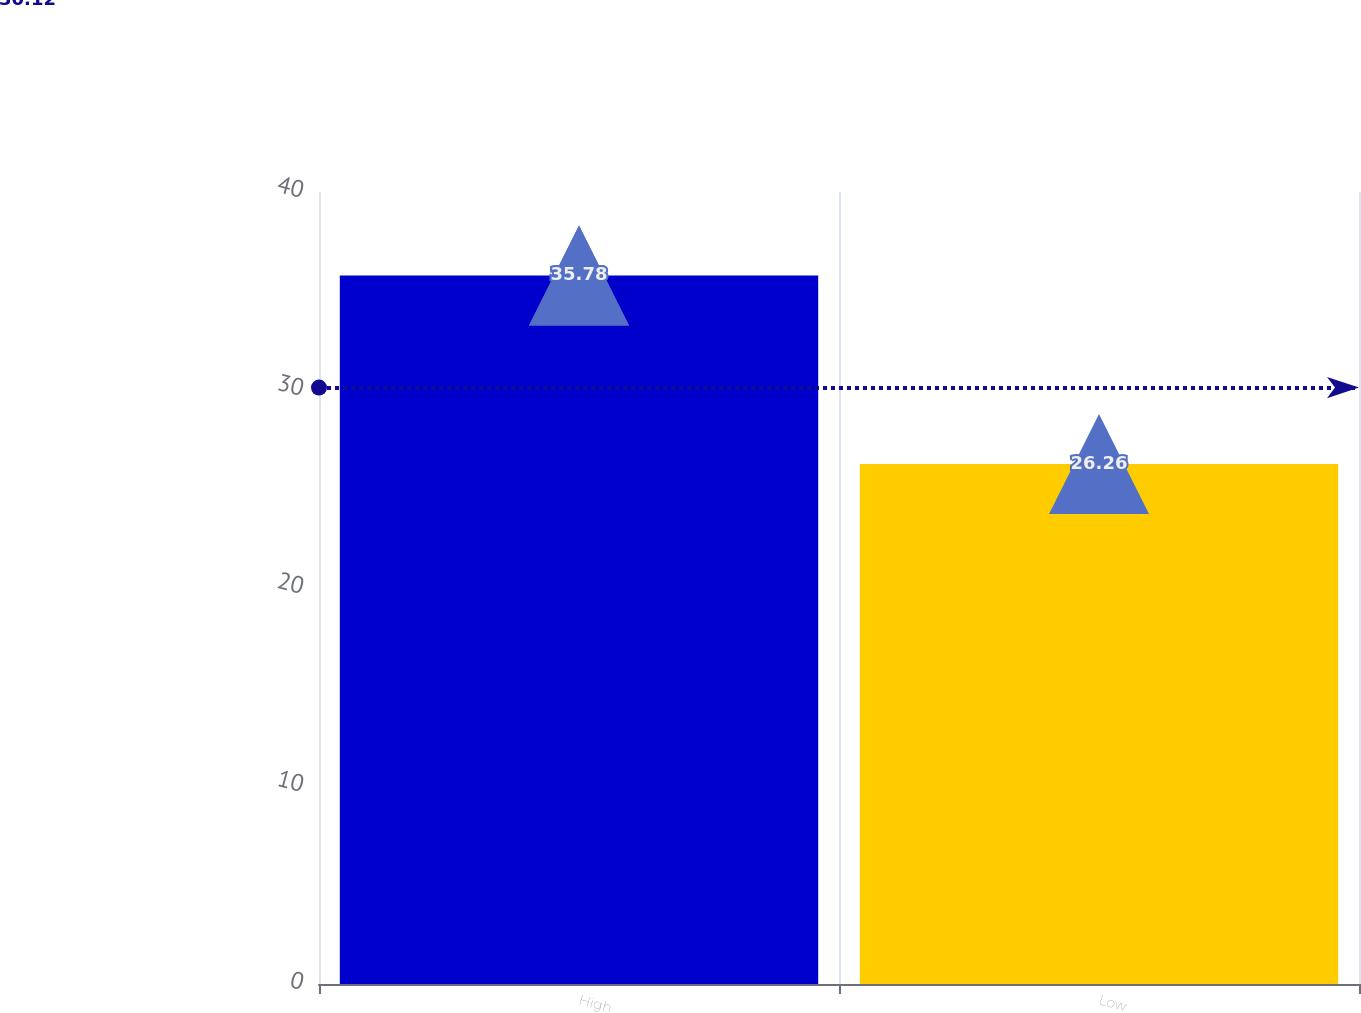<chart> <loc_0><loc_0><loc_500><loc_500><bar_chart><fcel>High<fcel>Low<nl><fcel>35.78<fcel>26.26<nl></chart> 